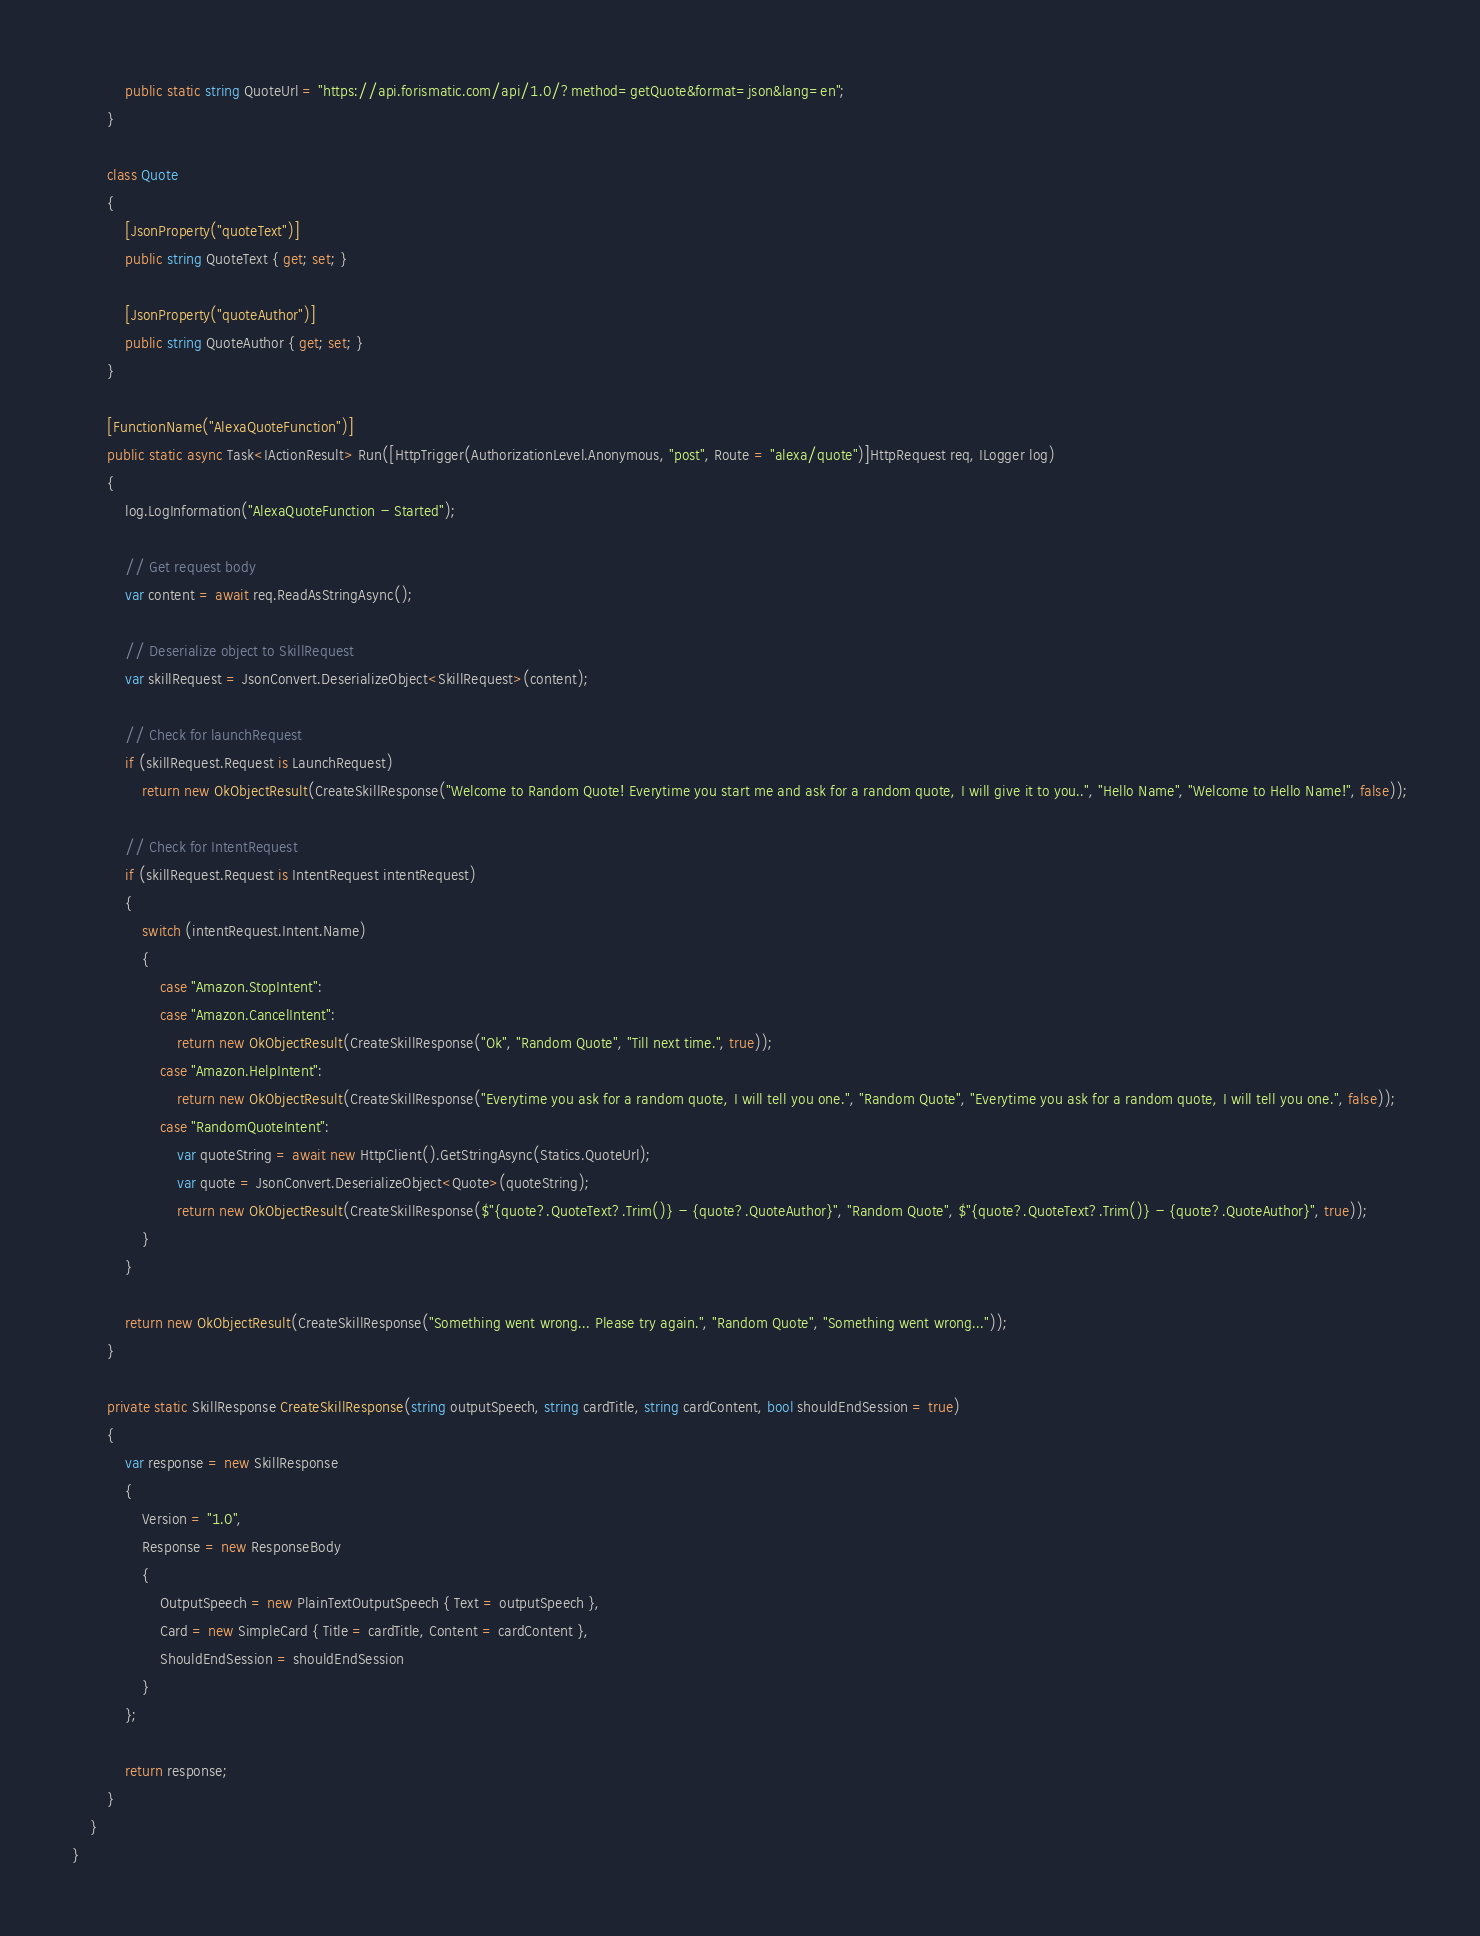Convert code to text. <code><loc_0><loc_0><loc_500><loc_500><_C#_>            public static string QuoteUrl = "https://api.forismatic.com/api/1.0/?method=getQuote&format=json&lang=en";
        }

        class Quote
        {
            [JsonProperty("quoteText")]
            public string QuoteText { get; set; }

            [JsonProperty("quoteAuthor")]
            public string QuoteAuthor { get; set; }
        }

        [FunctionName("AlexaQuoteFunction")]
        public static async Task<IActionResult> Run([HttpTrigger(AuthorizationLevel.Anonymous, "post", Route = "alexa/quote")]HttpRequest req, ILogger log)
        {
            log.LogInformation("AlexaQuoteFunction - Started");

            // Get request body
            var content = await req.ReadAsStringAsync();

            // Deserialize object to SkillRequest
            var skillRequest = JsonConvert.DeserializeObject<SkillRequest>(content);

            // Check for launchRequest
            if (skillRequest.Request is LaunchRequest)
                return new OkObjectResult(CreateSkillResponse("Welcome to Random Quote! Everytime you start me and ask for a random quote, I will give it to you..", "Hello Name", "Welcome to Hello Name!", false));

            // Check for IntentRequest
            if (skillRequest.Request is IntentRequest intentRequest)
            {
                switch (intentRequest.Intent.Name)
                {
                    case "Amazon.StopIntent":
                    case "Amazon.CancelIntent":
                        return new OkObjectResult(CreateSkillResponse("Ok", "Random Quote", "Till next time.", true));
                    case "Amazon.HelpIntent":
                        return new OkObjectResult(CreateSkillResponse("Everytime you ask for a random quote, I will tell you one.", "Random Quote", "Everytime you ask for a random quote, I will tell you one.", false));
                    case "RandomQuoteIntent":
                        var quoteString = await new HttpClient().GetStringAsync(Statics.QuoteUrl);
                        var quote = JsonConvert.DeserializeObject<Quote>(quoteString);
                        return new OkObjectResult(CreateSkillResponse($"{quote?.QuoteText?.Trim()} - {quote?.QuoteAuthor}", "Random Quote", $"{quote?.QuoteText?.Trim()} - {quote?.QuoteAuthor}", true));
                }
            }

            return new OkObjectResult(CreateSkillResponse("Something went wrong... Please try again.", "Random Quote", "Something went wrong..."));
        }

        private static SkillResponse CreateSkillResponse(string outputSpeech, string cardTitle, string cardContent, bool shouldEndSession = true)
        {
            var response = new SkillResponse
            {
                Version = "1.0",
                Response = new ResponseBody
                {
                    OutputSpeech = new PlainTextOutputSpeech { Text = outputSpeech },
                    Card = new SimpleCard { Title = cardTitle, Content = cardContent },
                    ShouldEndSession = shouldEndSession
                }
            };

            return response;
        }
    }
}
</code> 